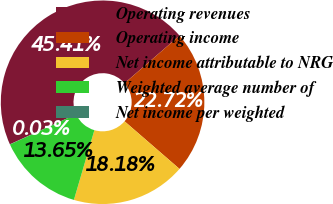Convert chart to OTSL. <chart><loc_0><loc_0><loc_500><loc_500><pie_chart><fcel>Operating revenues<fcel>Operating income<fcel>Net income attributable to NRG<fcel>Weighted average number of<fcel>Net income per weighted<nl><fcel>45.41%<fcel>22.72%<fcel>18.18%<fcel>13.65%<fcel>0.03%<nl></chart> 